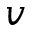<formula> <loc_0><loc_0><loc_500><loc_500>v</formula> 